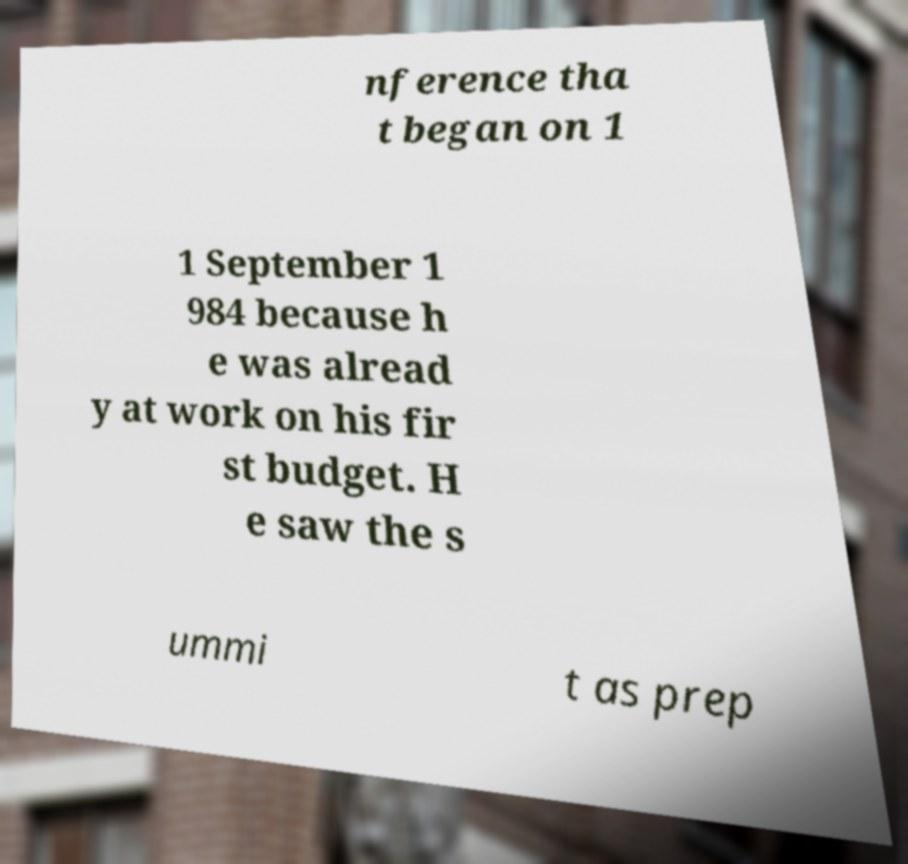Please identify and transcribe the text found in this image. nference tha t began on 1 1 September 1 984 because h e was alread y at work on his fir st budget. H e saw the s ummi t as prep 